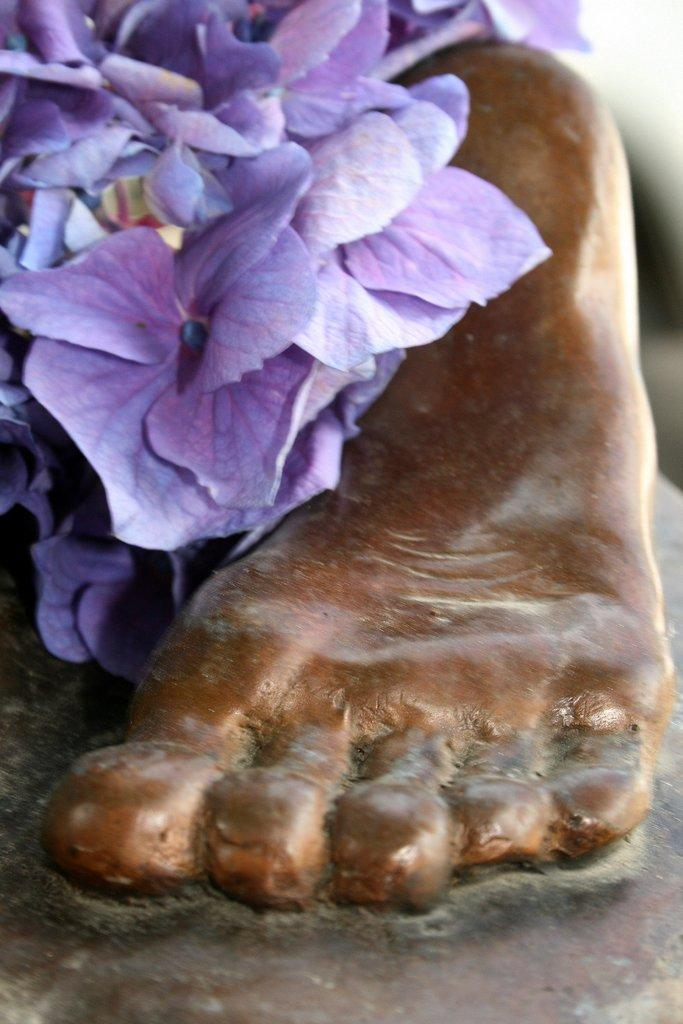What is the main subject of the image? The main subject of the image is a sculpture. Can you describe the sculpture in the image? The sculpture is of a person's leg. Are there any additional elements present on the sculpture? Yes, there are flowers on the sculpture. What type of trade is being conducted in the image? There is no indication of any trade being conducted in the image; it features a sculpture of a person's leg with flowers on it. Who is the son of the person depicted in the sculpture? There is no person depicted in the sculpture, as it only features a leg. 